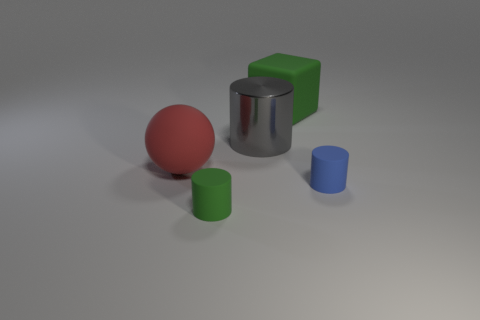Add 4 purple matte balls. How many objects exist? 9 Subtract all cylinders. How many objects are left? 2 Subtract 0 red cylinders. How many objects are left? 5 Subtract all large gray metal cylinders. Subtract all matte spheres. How many objects are left? 3 Add 4 cubes. How many cubes are left? 5 Add 3 cyan cubes. How many cyan cubes exist? 3 